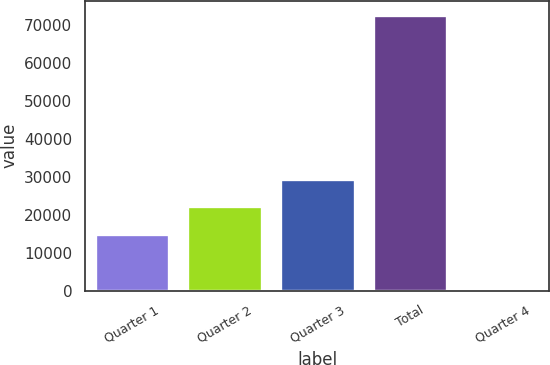Convert chart. <chart><loc_0><loc_0><loc_500><loc_500><bar_chart><fcel>Quarter 1<fcel>Quarter 2<fcel>Quarter 3<fcel>Total<fcel>Quarter 4<nl><fcel>14974<fcel>22247.1<fcel>29520.3<fcel>72740<fcel>8.67<nl></chart> 